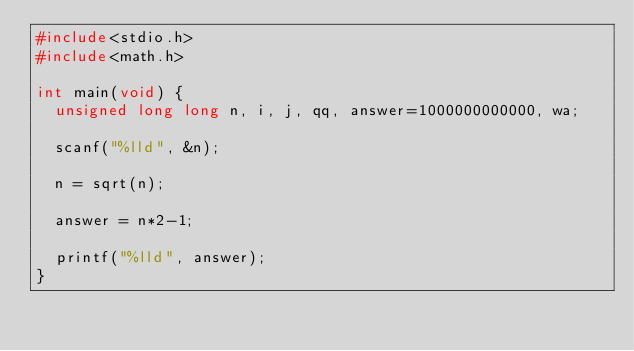Convert code to text. <code><loc_0><loc_0><loc_500><loc_500><_C_>#include<stdio.h>
#include<math.h>

int main(void) {
  unsigned long long n, i, j, qq, answer=1000000000000, wa;
  
  scanf("%lld", &n);
  
  n = sqrt(n);
  
  answer = n*2-1;
  
  printf("%lld", answer);
}
</code> 